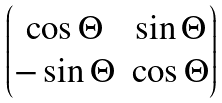Convert formula to latex. <formula><loc_0><loc_0><loc_500><loc_500>\begin{pmatrix} \cos \Theta & \sin \Theta \\ - \sin \Theta & \cos \Theta \end{pmatrix}</formula> 